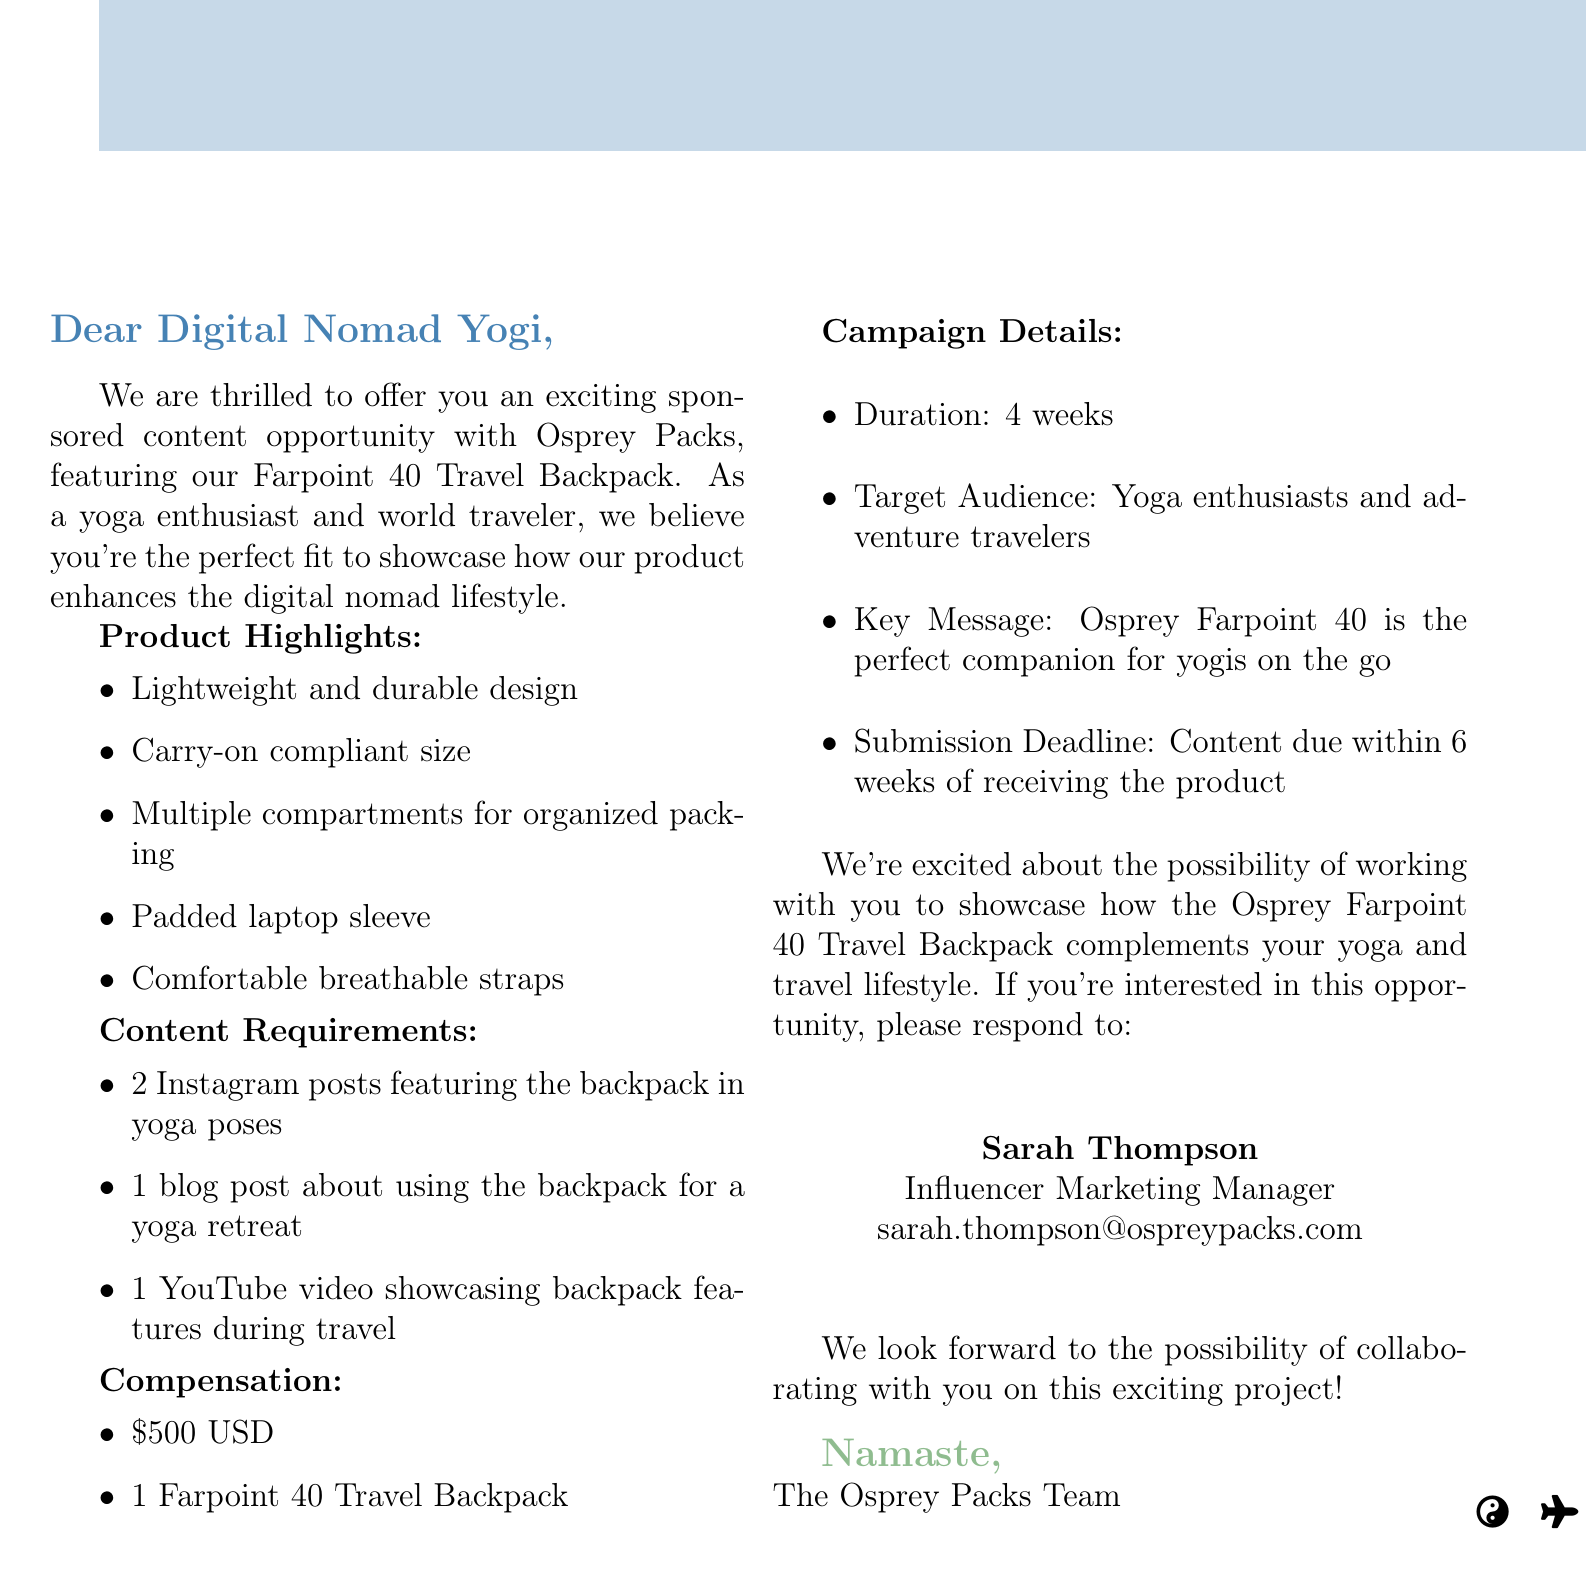What is the name of the company? The company mentioned in the document is Osprey Packs.
Answer: Osprey Packs What is the product being promoted? The email discusses the Farpoint 40 Travel Backpack.
Answer: Farpoint 40 Travel Backpack How many Instagram posts are required? The content requirements specify the number of Instagram posts needed for the campaign.
Answer: 2 What is the monetary compensation provided? The compensation section lists the monetary compensation for the sponsored content opportunity.
Answer: $500 USD What is the campaign duration? The information provided specifies how long the campaign will last.
Answer: 4 weeks Who is the contact person for this opportunity? The document includes the name of the contact person for inquiries regarding the opportunity.
Answer: Sarah Thompson What type of audience is this campaign targeting? The target audience is described in the campaign details.
Answer: Yoga enthusiasts and adventure travelers What is the submission deadline for the content? The email indicates when the content needs to be submitted after receiving the product.
Answer: 6 weeks What is a key message of the campaign? The document states the key message that the campaign aims to communicate.
Answer: Osprey Farpoint 40 is the perfect companion for yogis on the go 